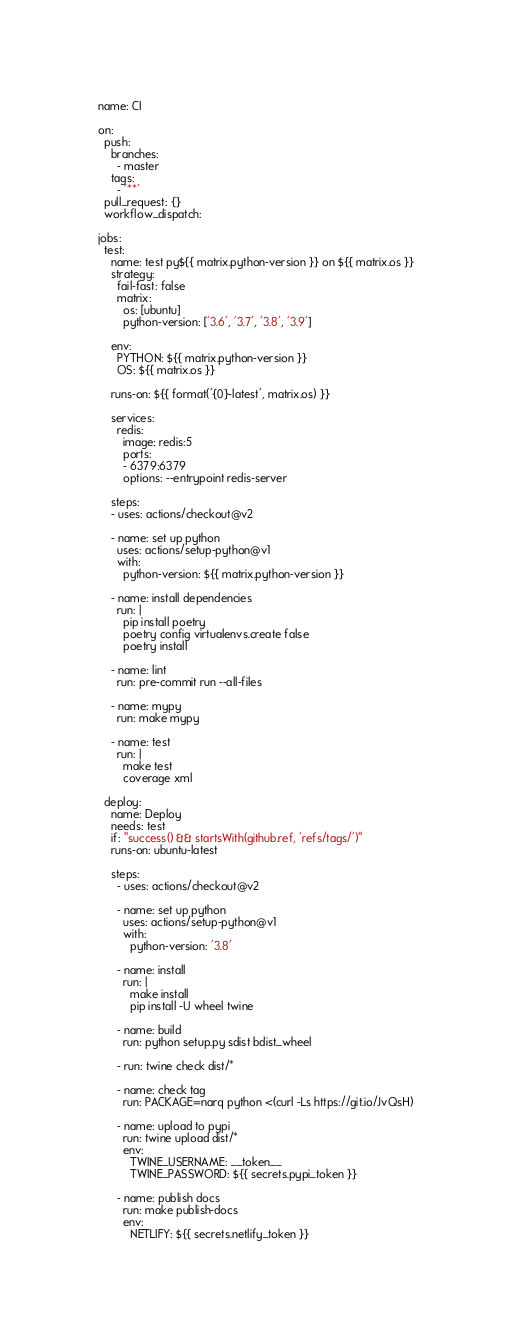Convert code to text. <code><loc_0><loc_0><loc_500><loc_500><_YAML_>name: CI

on:
  push:
    branches:
      - master
    tags:
      - '**'
  pull_request: {}
  workflow_dispatch:

jobs:
  test:
    name: test py${{ matrix.python-version }} on ${{ matrix.os }}
    strategy:
      fail-fast: false
      matrix:
        os: [ubuntu]
        python-version: ['3.6', '3.7', '3.8', '3.9']

    env:
      PYTHON: ${{ matrix.python-version }}
      OS: ${{ matrix.os }}

    runs-on: ${{ format('{0}-latest', matrix.os) }}

    services:
      redis:
        image: redis:5
        ports:
        - 6379:6379
        options: --entrypoint redis-server

    steps:
    - uses: actions/checkout@v2

    - name: set up python
      uses: actions/setup-python@v1
      with:
        python-version: ${{ matrix.python-version }}

    - name: install dependencies
      run: |
        pip install poetry
        poetry config virtualenvs.create false
        poetry install

    - name: lint
      run: pre-commit run --all-files

    - name: mypy
      run: make mypy

    - name: test
      run: |
        make test
        coverage xml

  deploy:
    name: Deploy
    needs: test
    if: "success() && startsWith(github.ref, 'refs/tags/')"
    runs-on: ubuntu-latest

    steps:
      - uses: actions/checkout@v2

      - name: set up python
        uses: actions/setup-python@v1
        with:
          python-version: '3.8'

      - name: install
        run: |
          make install
          pip install -U wheel twine

      - name: build
        run: python setup.py sdist bdist_wheel

      - run: twine check dist/*

      - name: check tag
        run: PACKAGE=narq python <(curl -Ls https://git.io/JvQsH)

      - name: upload to pypi
        run: twine upload dist/*
        env:
          TWINE_USERNAME: __token__
          TWINE_PASSWORD: ${{ secrets.pypi_token }}

      - name: publish docs
        run: make publish-docs
        env:
          NETLIFY: ${{ secrets.netlify_token }}
</code> 